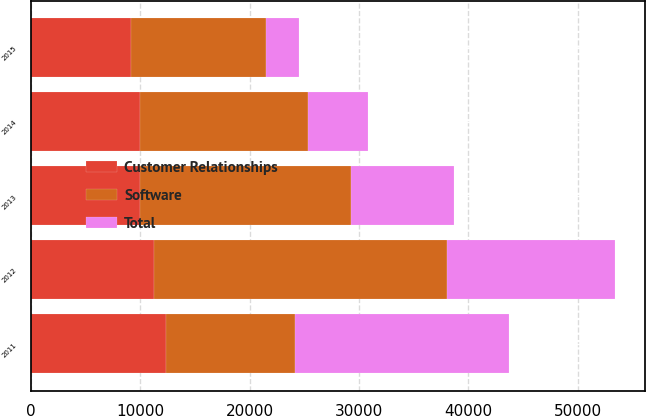<chart> <loc_0><loc_0><loc_500><loc_500><stacked_bar_chart><ecel><fcel>2011<fcel>2012<fcel>2013<fcel>2014<fcel>2015<nl><fcel>Customer Relationships<fcel>12326<fcel>11299<fcel>9935<fcel>9935<fcel>9180<nl><fcel>Total<fcel>19616<fcel>15428<fcel>9430<fcel>5456<fcel>3097<nl><fcel>Software<fcel>11788<fcel>26727<fcel>19365<fcel>15391<fcel>12277<nl></chart> 